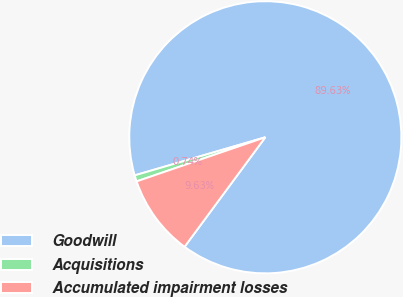Convert chart to OTSL. <chart><loc_0><loc_0><loc_500><loc_500><pie_chart><fcel>Goodwill<fcel>Acquisitions<fcel>Accumulated impairment losses<nl><fcel>89.63%<fcel>0.74%<fcel>9.63%<nl></chart> 